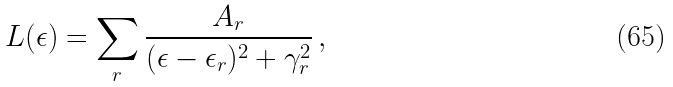Convert formula to latex. <formula><loc_0><loc_0><loc_500><loc_500>L ( \epsilon ) = \sum _ { r } \frac { A _ { r } } { ( \epsilon - \epsilon _ { r } ) ^ { 2 } + \gamma _ { r } ^ { 2 } } \, ,</formula> 